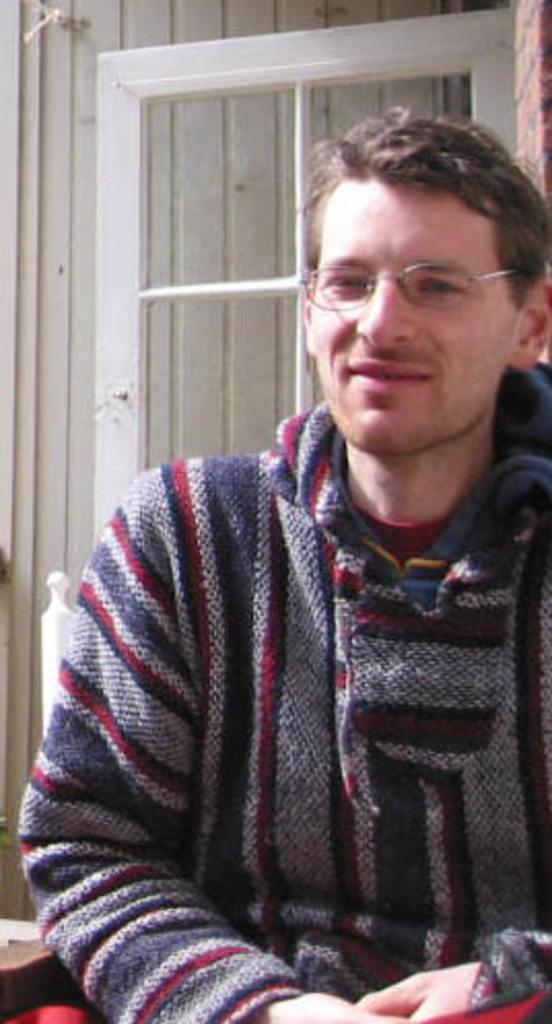What is the main subject of the image? The main subject of the image is a man. What is the man wearing in the image? The man is wearing a jacket in the image. What is the man's facial expression in the image? The man is smiling in the image. What is the man doing in the image? The man is posing for the picture in the image. What can be seen in the background of the image? There is a wall and a wooden door in the background of the image. How many fingers does the man's brother have in the image? There is no mention of a brother or fingers in the image; it only features a man wearing a jacket, smiling, and posing for the picture. 